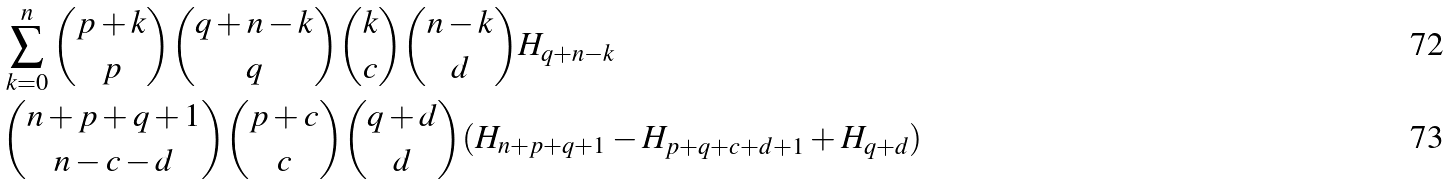Convert formula to latex. <formula><loc_0><loc_0><loc_500><loc_500>& \sum _ { k = 0 } ^ { n } \binom { p + k } { p } \binom { q + n - k } { q } \binom { k } { c } \binom { n - k } { d } H _ { q + n - k } \\ & \binom { n + p + q + 1 } { n - c - d } \binom { p + c } { c } \binom { q + d } { d } ( H _ { n + p + q + 1 } - H _ { p + q + c + d + 1 } + H _ { q + d } )</formula> 